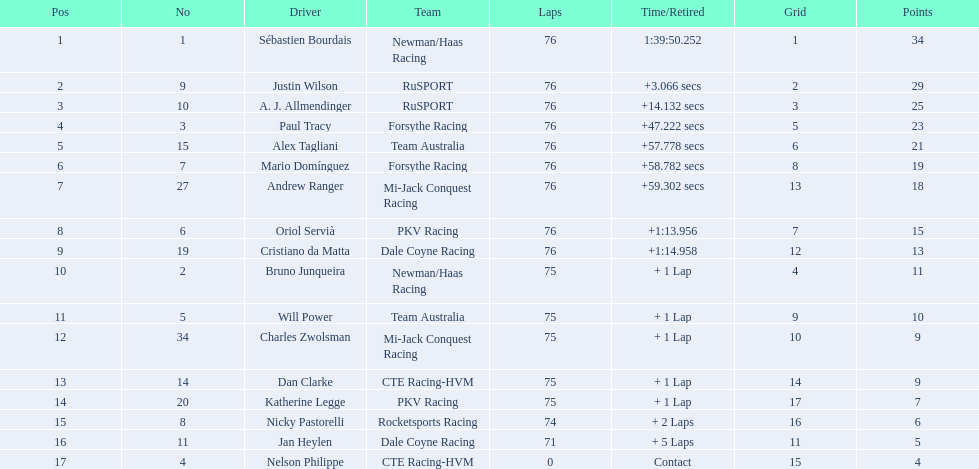What was the ultimate score of alex taglini in the tecate grand prix? 21. What was the final score for paul tracy in that race? 23. Who was the driver who finished at the top? Paul Tracy. 